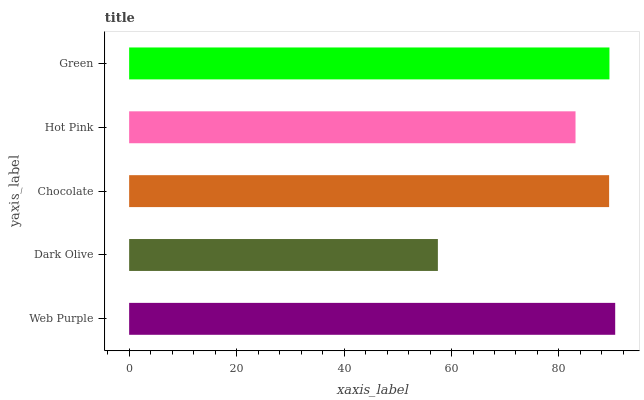Is Dark Olive the minimum?
Answer yes or no. Yes. Is Web Purple the maximum?
Answer yes or no. Yes. Is Chocolate the minimum?
Answer yes or no. No. Is Chocolate the maximum?
Answer yes or no. No. Is Chocolate greater than Dark Olive?
Answer yes or no. Yes. Is Dark Olive less than Chocolate?
Answer yes or no. Yes. Is Dark Olive greater than Chocolate?
Answer yes or no. No. Is Chocolate less than Dark Olive?
Answer yes or no. No. Is Chocolate the high median?
Answer yes or no. Yes. Is Chocolate the low median?
Answer yes or no. Yes. Is Hot Pink the high median?
Answer yes or no. No. Is Dark Olive the low median?
Answer yes or no. No. 